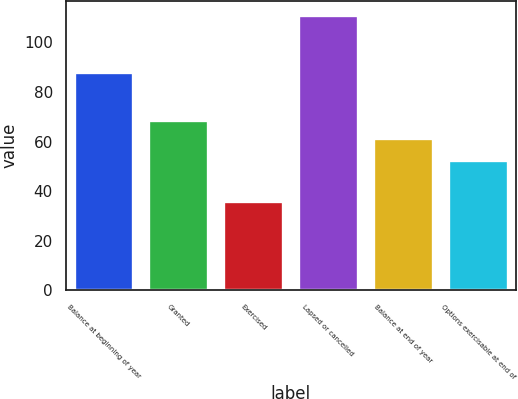Convert chart. <chart><loc_0><loc_0><loc_500><loc_500><bar_chart><fcel>Balance at beginning of year<fcel>Granted<fcel>Exercised<fcel>Lapsed or cancelled<fcel>Balance at end of year<fcel>Options exercisable at end of<nl><fcel>88.21<fcel>68.84<fcel>36.08<fcel>111.23<fcel>61.33<fcel>52.55<nl></chart> 